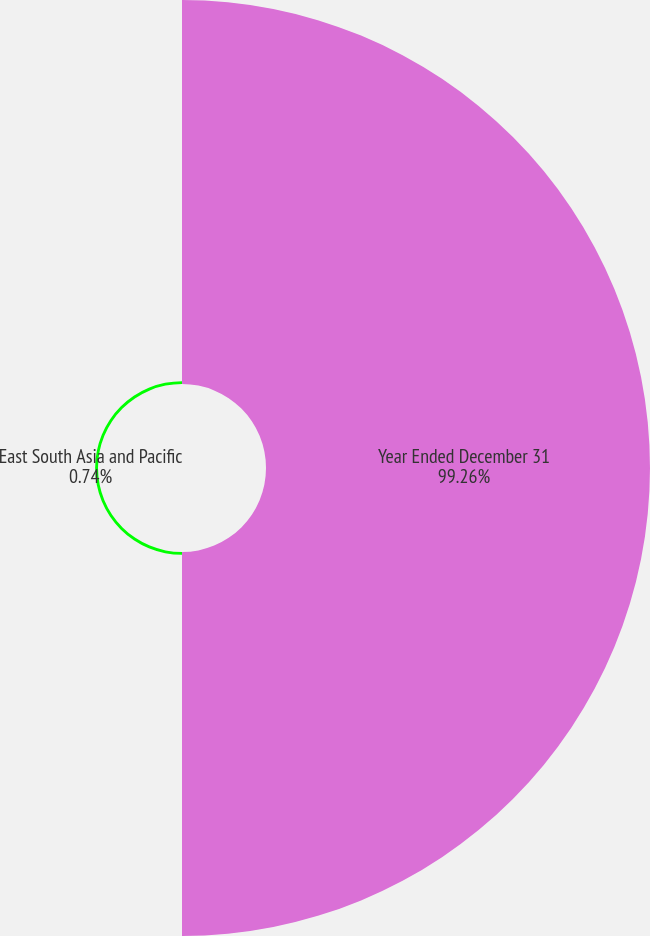<chart> <loc_0><loc_0><loc_500><loc_500><pie_chart><fcel>Year Ended December 31<fcel>East South Asia and Pacific<nl><fcel>99.26%<fcel>0.74%<nl></chart> 